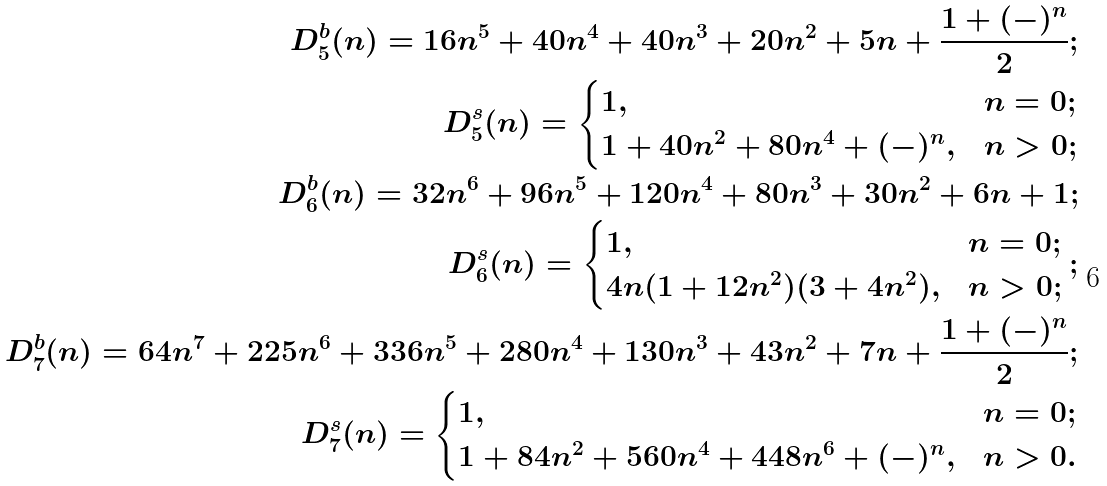<formula> <loc_0><loc_0><loc_500><loc_500>D _ { 5 } ^ { b } ( n ) = 1 6 n ^ { 5 } + 4 0 n ^ { 4 } + 4 0 n ^ { 3 } + 2 0 n ^ { 2 } + 5 n + \frac { 1 + ( - ) ^ { n } } { 2 } ; \\ D _ { 5 } ^ { s } ( n ) = \begin{cases} 1 , & n = 0 ; \\ 1 + 4 0 n ^ { 2 } + 8 0 n ^ { 4 } + ( - ) ^ { n } , & n > 0 ; \end{cases} \\ D _ { 6 } ^ { b } ( n ) = 3 2 n ^ { 6 } + 9 6 n ^ { 5 } + 1 2 0 n ^ { 4 } + 8 0 n ^ { 3 } + 3 0 n ^ { 2 } + 6 n + 1 ; \\ D _ { 6 } ^ { s } ( n ) = \begin{cases} 1 , & n = 0 ; \\ 4 n ( 1 + 1 2 n ^ { 2 } ) ( 3 + 4 n ^ { 2 } ) , & n > 0 ; \end{cases} ; \\ D _ { 7 } ^ { b } ( n ) = 6 4 n ^ { 7 } + 2 2 5 n ^ { 6 } + 3 3 6 n ^ { 5 } + 2 8 0 n ^ { 4 } + 1 3 0 n ^ { 3 } + 4 3 n ^ { 2 } + 7 n + \frac { 1 + ( - ) ^ { n } } { 2 } ; \\ D _ { 7 } ^ { s } ( n ) = \begin{cases} 1 , & n = 0 ; \\ 1 + 8 4 n ^ { 2 } + 5 6 0 n ^ { 4 } + 4 4 8 n ^ { 6 } + ( - ) ^ { n } , & n > 0 . \end{cases}</formula> 